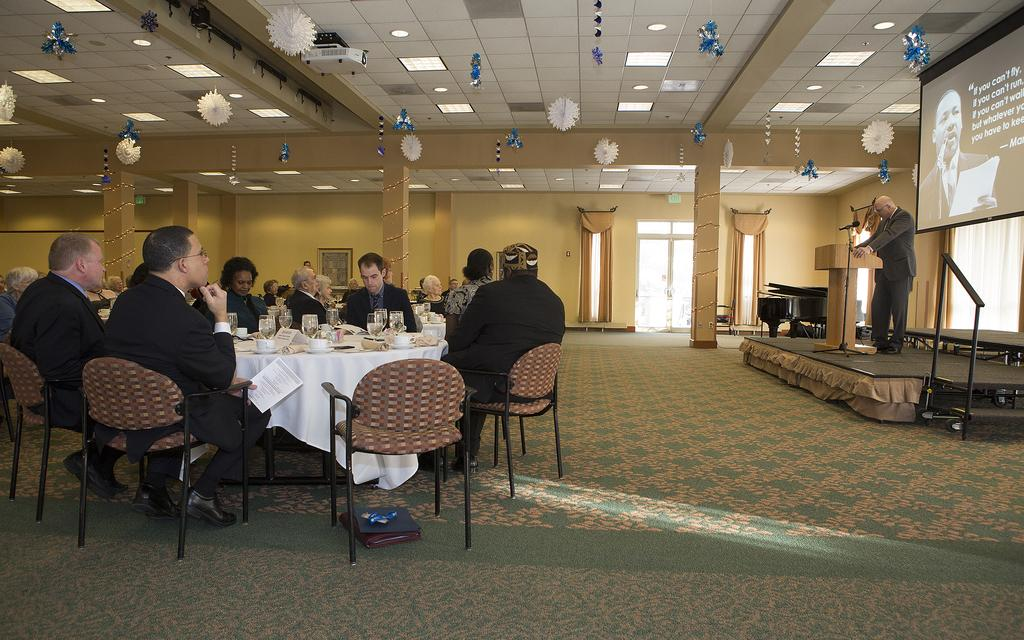What is the man at the podium doing on the stage? The man is standing at a podium on a stage, which suggests he is giving a speech or presentation. What can be seen behind the man on the stage? There is a screen behind the man. How are the people arranged in the hall? The people are sitting in groups at tables. What are the people doing while the man is on stage? The people are listening to the man. How is the hall decorated? The hall is well decorated. What type of feast is being prepared on the stage? There is no mention of a feast being prepared in the image; the man is standing at a podium giving a speech or presentation. Can you describe the zephyr blowing through the hall? There is no mention of a zephyr or any breeze in the image; the focus is on the man at the podium and the people listening to him. 